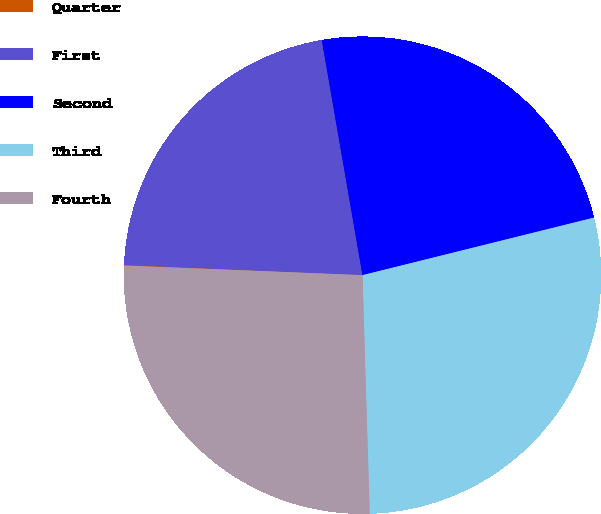<chart> <loc_0><loc_0><loc_500><loc_500><pie_chart><fcel>Quarter<fcel>First<fcel>Second<fcel>Third<fcel>Fourth<nl><fcel>0.05%<fcel>21.58%<fcel>23.85%<fcel>28.39%<fcel>26.12%<nl></chart> 